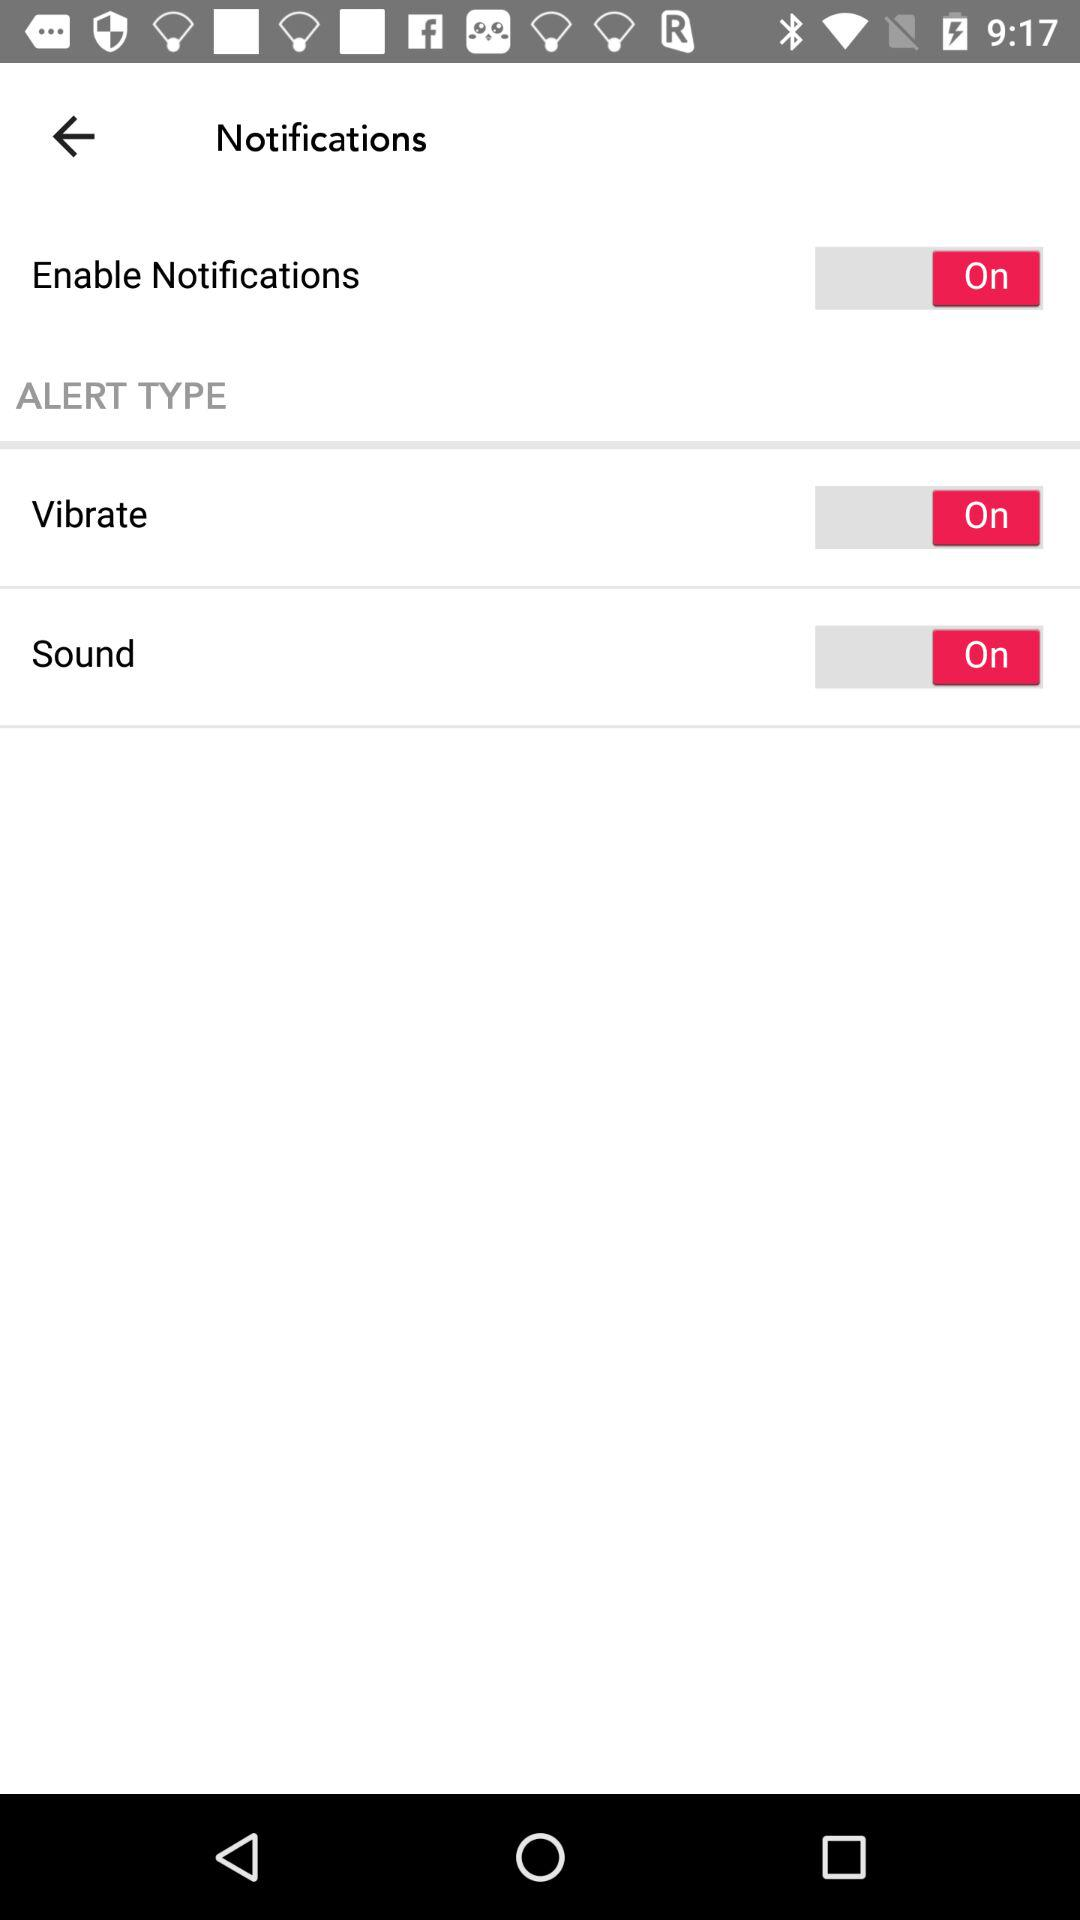What is the status of "Enable Notifications"? The status is "on". 